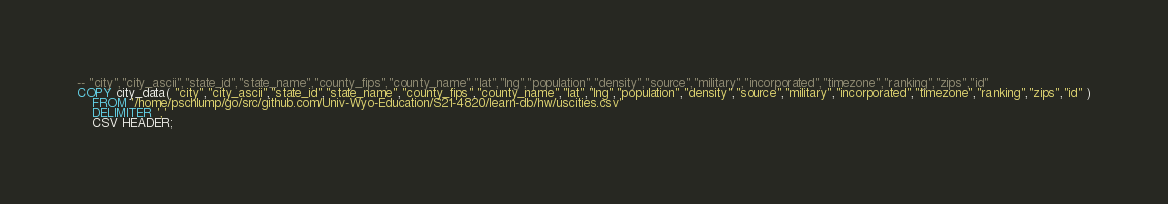Convert code to text. <code><loc_0><loc_0><loc_500><loc_500><_SQL_>-- "city","city_ascii","state_id","state_name","county_fips","county_name","lat","lng","population","density","source","military","incorporated","timezone","ranking","zips","id"
COPY city_data( "city","city_ascii","state_id","state_name","county_fips","county_name","lat","lng","population","density","source","military","incorporated","timezone","ranking","zips","id" )
	FROM '/home/pschlump/go/src/github.com/Univ-Wyo-Education/S21-4820/learn-db/hw/uscities.csv'
	DELIMITER ','
	CSV HEADER;
</code> 